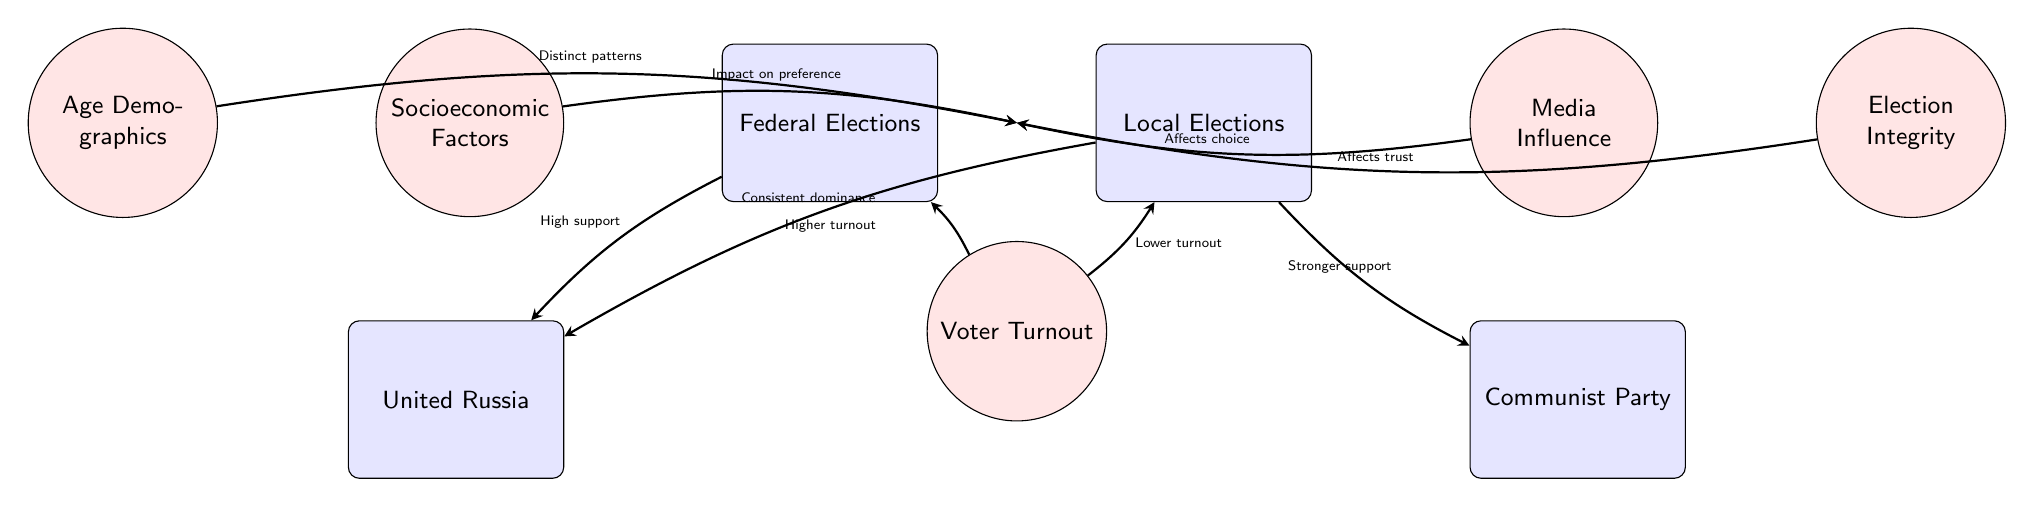What is the main political party depicted in the federal elections? The diagram shows "United Russia" as the political party associated with federal elections, indicated by its connection from the federal election node.
Answer: United Russia What type of elections shows stronger support for the Communist Party? The diagram indicates that the Communist Party receives stronger support in local elections, as shown by the arrow pointing from local elections to the Communist Party.
Answer: Local Elections How does voter turnout compare between federal and local elections? According to the diagram, voter turnout is higher in federal elections and lower in local elections, demonstrated by the arrows leading to the turnout node.
Answer: Higher in Federal What influences voter choice according to the diagram? The diagram states that media influence affects voter choice, represented by the arrow from the media node to the central node of voter turnout.
Answer: Media Influence What is indicated about socioeconomic factors and voting preferences? The diagram suggests that socioeconomic factors have an impact on voter preference, as indicated by the arrow from the socioeconomic factors node to the central voting patterns node.
Answer: Impact on preference How many political parties are explicitly shown in the diagram? The diagram highlights two political parties: United Russia and the Communist Party, hence that counts as two specific parties.
Answer: Two What demographic factor is highlighted in the diagram regarding voting patterns? The age demographics are specifically mentioned, with its influence shown through the arrow towards the central node of voting patterns.
Answer: Age Demographics Which local political context is emphasized in the diagram? The diagram emphasizes the local elections context particularly with respect to the consistent dominance of United Russia and the stronger support for the Communist Party.
Answer: Local Elections How do the two types of elections relate to voter turnout? The diagram shows a direct relationship where federal elections result in higher voter turnout compared to local elections, indicated by the arrows pointing in opposite directions from the turnout node.
Answer: Higher in Federal, Lower in Local 